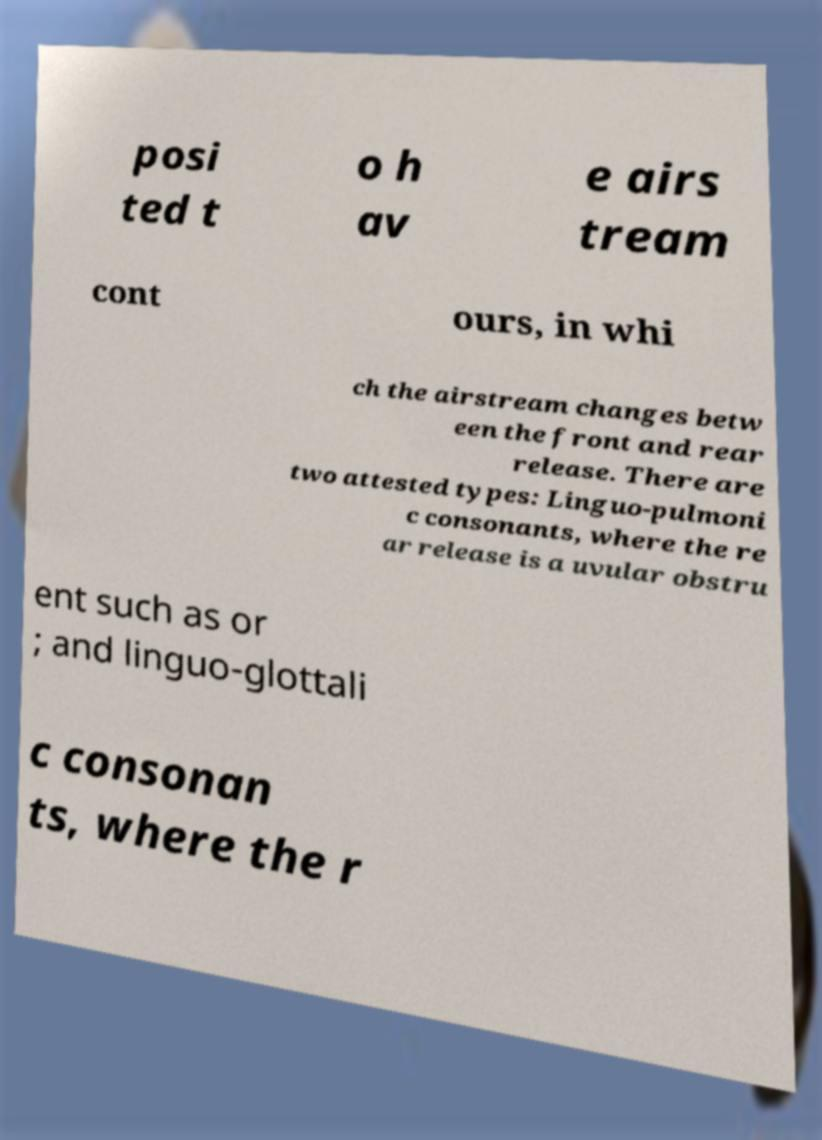I need the written content from this picture converted into text. Can you do that? posi ted t o h av e airs tream cont ours, in whi ch the airstream changes betw een the front and rear release. There are two attested types: Linguo-pulmoni c consonants, where the re ar release is a uvular obstru ent such as or ; and linguo-glottali c consonan ts, where the r 